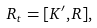<formula> <loc_0><loc_0><loc_500><loc_500>R _ { t } = [ K ^ { \prime } , R ] ,</formula> 